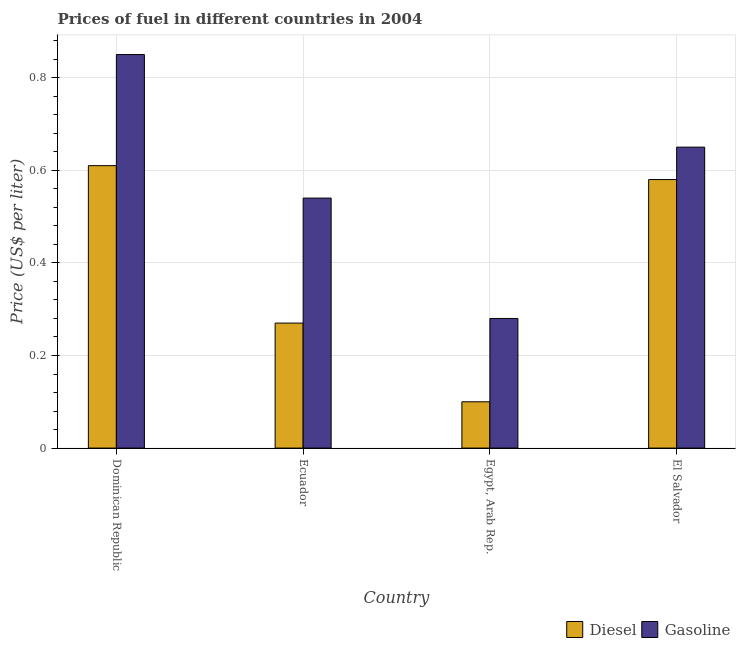How many different coloured bars are there?
Offer a terse response. 2. How many bars are there on the 3rd tick from the left?
Offer a very short reply. 2. How many bars are there on the 3rd tick from the right?
Provide a short and direct response. 2. What is the label of the 1st group of bars from the left?
Your answer should be very brief. Dominican Republic. Across all countries, what is the maximum diesel price?
Your answer should be very brief. 0.61. Across all countries, what is the minimum gasoline price?
Give a very brief answer. 0.28. In which country was the diesel price maximum?
Your response must be concise. Dominican Republic. In which country was the gasoline price minimum?
Your answer should be very brief. Egypt, Arab Rep. What is the total diesel price in the graph?
Give a very brief answer. 1.56. What is the difference between the gasoline price in Dominican Republic and that in El Salvador?
Provide a succinct answer. 0.2. What is the difference between the diesel price in El Salvador and the gasoline price in Egypt, Arab Rep.?
Keep it short and to the point. 0.3. What is the average gasoline price per country?
Provide a succinct answer. 0.58. What is the difference between the diesel price and gasoline price in Dominican Republic?
Your answer should be compact. -0.24. In how many countries, is the gasoline price greater than 0.4 US$ per litre?
Provide a succinct answer. 3. What is the ratio of the gasoline price in Egypt, Arab Rep. to that in El Salvador?
Your answer should be compact. 0.43. What is the difference between the highest and the second highest diesel price?
Your answer should be very brief. 0.03. What is the difference between the highest and the lowest gasoline price?
Offer a very short reply. 0.57. In how many countries, is the gasoline price greater than the average gasoline price taken over all countries?
Your response must be concise. 2. Is the sum of the diesel price in Dominican Republic and Egypt, Arab Rep. greater than the maximum gasoline price across all countries?
Make the answer very short. No. What does the 1st bar from the left in Egypt, Arab Rep. represents?
Offer a terse response. Diesel. What does the 2nd bar from the right in El Salvador represents?
Offer a terse response. Diesel. Are all the bars in the graph horizontal?
Your answer should be compact. No. How many countries are there in the graph?
Ensure brevity in your answer.  4. Are the values on the major ticks of Y-axis written in scientific E-notation?
Give a very brief answer. No. Does the graph contain grids?
Provide a short and direct response. Yes. How many legend labels are there?
Your response must be concise. 2. How are the legend labels stacked?
Keep it short and to the point. Horizontal. What is the title of the graph?
Keep it short and to the point. Prices of fuel in different countries in 2004. Does "Transport services" appear as one of the legend labels in the graph?
Provide a succinct answer. No. What is the label or title of the X-axis?
Your answer should be very brief. Country. What is the label or title of the Y-axis?
Your response must be concise. Price (US$ per liter). What is the Price (US$ per liter) in Diesel in Dominican Republic?
Offer a very short reply. 0.61. What is the Price (US$ per liter) of Gasoline in Dominican Republic?
Make the answer very short. 0.85. What is the Price (US$ per liter) of Diesel in Ecuador?
Make the answer very short. 0.27. What is the Price (US$ per liter) in Gasoline in Ecuador?
Offer a terse response. 0.54. What is the Price (US$ per liter) of Diesel in Egypt, Arab Rep.?
Provide a succinct answer. 0.1. What is the Price (US$ per liter) of Gasoline in Egypt, Arab Rep.?
Provide a succinct answer. 0.28. What is the Price (US$ per liter) in Diesel in El Salvador?
Make the answer very short. 0.58. What is the Price (US$ per liter) of Gasoline in El Salvador?
Provide a short and direct response. 0.65. Across all countries, what is the maximum Price (US$ per liter) in Diesel?
Your response must be concise. 0.61. Across all countries, what is the maximum Price (US$ per liter) of Gasoline?
Keep it short and to the point. 0.85. Across all countries, what is the minimum Price (US$ per liter) in Diesel?
Give a very brief answer. 0.1. Across all countries, what is the minimum Price (US$ per liter) of Gasoline?
Keep it short and to the point. 0.28. What is the total Price (US$ per liter) of Diesel in the graph?
Your answer should be very brief. 1.56. What is the total Price (US$ per liter) in Gasoline in the graph?
Give a very brief answer. 2.32. What is the difference between the Price (US$ per liter) of Diesel in Dominican Republic and that in Ecuador?
Provide a short and direct response. 0.34. What is the difference between the Price (US$ per liter) of Gasoline in Dominican Republic and that in Ecuador?
Offer a very short reply. 0.31. What is the difference between the Price (US$ per liter) of Diesel in Dominican Republic and that in Egypt, Arab Rep.?
Make the answer very short. 0.51. What is the difference between the Price (US$ per liter) in Gasoline in Dominican Republic and that in Egypt, Arab Rep.?
Ensure brevity in your answer.  0.57. What is the difference between the Price (US$ per liter) of Diesel in Ecuador and that in Egypt, Arab Rep.?
Offer a terse response. 0.17. What is the difference between the Price (US$ per liter) in Gasoline in Ecuador and that in Egypt, Arab Rep.?
Offer a very short reply. 0.26. What is the difference between the Price (US$ per liter) in Diesel in Ecuador and that in El Salvador?
Offer a terse response. -0.31. What is the difference between the Price (US$ per liter) in Gasoline in Ecuador and that in El Salvador?
Your answer should be compact. -0.11. What is the difference between the Price (US$ per liter) in Diesel in Egypt, Arab Rep. and that in El Salvador?
Ensure brevity in your answer.  -0.48. What is the difference between the Price (US$ per liter) of Gasoline in Egypt, Arab Rep. and that in El Salvador?
Your response must be concise. -0.37. What is the difference between the Price (US$ per liter) of Diesel in Dominican Republic and the Price (US$ per liter) of Gasoline in Ecuador?
Give a very brief answer. 0.07. What is the difference between the Price (US$ per liter) in Diesel in Dominican Republic and the Price (US$ per liter) in Gasoline in Egypt, Arab Rep.?
Ensure brevity in your answer.  0.33. What is the difference between the Price (US$ per liter) of Diesel in Dominican Republic and the Price (US$ per liter) of Gasoline in El Salvador?
Ensure brevity in your answer.  -0.04. What is the difference between the Price (US$ per liter) of Diesel in Ecuador and the Price (US$ per liter) of Gasoline in Egypt, Arab Rep.?
Provide a short and direct response. -0.01. What is the difference between the Price (US$ per liter) of Diesel in Ecuador and the Price (US$ per liter) of Gasoline in El Salvador?
Offer a terse response. -0.38. What is the difference between the Price (US$ per liter) in Diesel in Egypt, Arab Rep. and the Price (US$ per liter) in Gasoline in El Salvador?
Ensure brevity in your answer.  -0.55. What is the average Price (US$ per liter) in Diesel per country?
Offer a terse response. 0.39. What is the average Price (US$ per liter) of Gasoline per country?
Ensure brevity in your answer.  0.58. What is the difference between the Price (US$ per liter) in Diesel and Price (US$ per liter) in Gasoline in Dominican Republic?
Provide a succinct answer. -0.24. What is the difference between the Price (US$ per liter) in Diesel and Price (US$ per liter) in Gasoline in Ecuador?
Your answer should be very brief. -0.27. What is the difference between the Price (US$ per liter) in Diesel and Price (US$ per liter) in Gasoline in Egypt, Arab Rep.?
Offer a terse response. -0.18. What is the difference between the Price (US$ per liter) in Diesel and Price (US$ per liter) in Gasoline in El Salvador?
Provide a short and direct response. -0.07. What is the ratio of the Price (US$ per liter) in Diesel in Dominican Republic to that in Ecuador?
Make the answer very short. 2.26. What is the ratio of the Price (US$ per liter) in Gasoline in Dominican Republic to that in Ecuador?
Give a very brief answer. 1.57. What is the ratio of the Price (US$ per liter) in Gasoline in Dominican Republic to that in Egypt, Arab Rep.?
Offer a terse response. 3.04. What is the ratio of the Price (US$ per liter) of Diesel in Dominican Republic to that in El Salvador?
Provide a succinct answer. 1.05. What is the ratio of the Price (US$ per liter) of Gasoline in Dominican Republic to that in El Salvador?
Offer a very short reply. 1.31. What is the ratio of the Price (US$ per liter) in Gasoline in Ecuador to that in Egypt, Arab Rep.?
Provide a succinct answer. 1.93. What is the ratio of the Price (US$ per liter) of Diesel in Ecuador to that in El Salvador?
Make the answer very short. 0.47. What is the ratio of the Price (US$ per liter) of Gasoline in Ecuador to that in El Salvador?
Make the answer very short. 0.83. What is the ratio of the Price (US$ per liter) of Diesel in Egypt, Arab Rep. to that in El Salvador?
Give a very brief answer. 0.17. What is the ratio of the Price (US$ per liter) of Gasoline in Egypt, Arab Rep. to that in El Salvador?
Offer a very short reply. 0.43. What is the difference between the highest and the second highest Price (US$ per liter) in Gasoline?
Your answer should be compact. 0.2. What is the difference between the highest and the lowest Price (US$ per liter) of Diesel?
Ensure brevity in your answer.  0.51. What is the difference between the highest and the lowest Price (US$ per liter) in Gasoline?
Your answer should be compact. 0.57. 